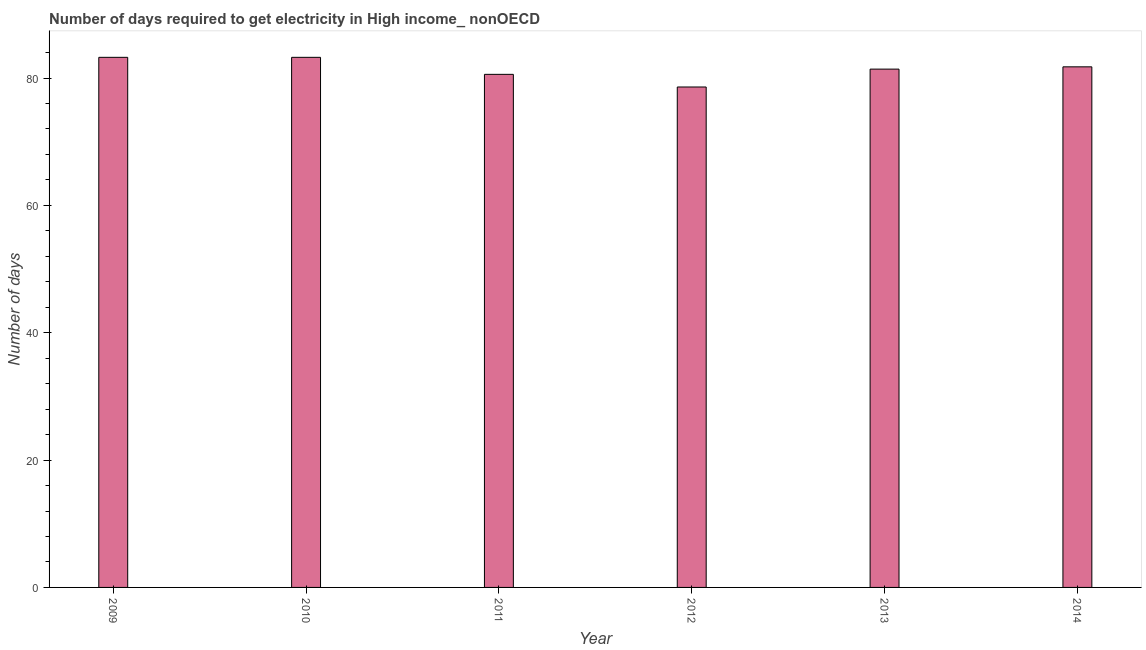Does the graph contain grids?
Give a very brief answer. No. What is the title of the graph?
Provide a short and direct response. Number of days required to get electricity in High income_ nonOECD. What is the label or title of the X-axis?
Offer a very short reply. Year. What is the label or title of the Y-axis?
Offer a terse response. Number of days. What is the time to get electricity in 2011?
Provide a short and direct response. 80.58. Across all years, what is the maximum time to get electricity?
Provide a succinct answer. 83.25. Across all years, what is the minimum time to get electricity?
Make the answer very short. 78.59. In which year was the time to get electricity maximum?
Provide a succinct answer. 2009. What is the sum of the time to get electricity?
Provide a short and direct response. 488.83. What is the difference between the time to get electricity in 2011 and 2013?
Your answer should be very brief. -0.82. What is the average time to get electricity per year?
Make the answer very short. 81.47. What is the median time to get electricity?
Provide a short and direct response. 81.58. In how many years, is the time to get electricity greater than 68 ?
Offer a very short reply. 6. Do a majority of the years between 2009 and 2010 (inclusive) have time to get electricity greater than 16 ?
Your answer should be compact. Yes. Is the difference between the time to get electricity in 2009 and 2014 greater than the difference between any two years?
Keep it short and to the point. No. What is the difference between the highest and the second highest time to get electricity?
Provide a short and direct response. 0. What is the difference between the highest and the lowest time to get electricity?
Your answer should be very brief. 4.66. Are all the bars in the graph horizontal?
Your answer should be compact. No. How many years are there in the graph?
Your answer should be compact. 6. Are the values on the major ticks of Y-axis written in scientific E-notation?
Your answer should be compact. No. What is the Number of days of 2009?
Make the answer very short. 83.25. What is the Number of days in 2010?
Provide a succinct answer. 83.25. What is the Number of days of 2011?
Offer a very short reply. 80.58. What is the Number of days of 2012?
Provide a short and direct response. 78.59. What is the Number of days of 2013?
Keep it short and to the point. 81.4. What is the Number of days in 2014?
Your response must be concise. 81.76. What is the difference between the Number of days in 2009 and 2011?
Provide a short and direct response. 2.67. What is the difference between the Number of days in 2009 and 2012?
Your response must be concise. 4.66. What is the difference between the Number of days in 2009 and 2013?
Keep it short and to the point. 1.85. What is the difference between the Number of days in 2009 and 2014?
Give a very brief answer. 1.49. What is the difference between the Number of days in 2010 and 2011?
Provide a short and direct response. 2.67. What is the difference between the Number of days in 2010 and 2012?
Your answer should be very brief. 4.66. What is the difference between the Number of days in 2010 and 2013?
Your answer should be very brief. 1.85. What is the difference between the Number of days in 2010 and 2014?
Your answer should be very brief. 1.49. What is the difference between the Number of days in 2011 and 2012?
Give a very brief answer. 1.98. What is the difference between the Number of days in 2011 and 2013?
Your answer should be compact. -0.82. What is the difference between the Number of days in 2011 and 2014?
Your answer should be compact. -1.18. What is the difference between the Number of days in 2012 and 2013?
Make the answer very short. -2.81. What is the difference between the Number of days in 2012 and 2014?
Your answer should be very brief. -3.16. What is the difference between the Number of days in 2013 and 2014?
Provide a succinct answer. -0.36. What is the ratio of the Number of days in 2009 to that in 2010?
Provide a short and direct response. 1. What is the ratio of the Number of days in 2009 to that in 2011?
Your answer should be very brief. 1.03. What is the ratio of the Number of days in 2009 to that in 2012?
Your response must be concise. 1.06. What is the ratio of the Number of days in 2009 to that in 2013?
Your answer should be compact. 1.02. What is the ratio of the Number of days in 2009 to that in 2014?
Offer a very short reply. 1.02. What is the ratio of the Number of days in 2010 to that in 2011?
Make the answer very short. 1.03. What is the ratio of the Number of days in 2010 to that in 2012?
Provide a succinct answer. 1.06. What is the ratio of the Number of days in 2011 to that in 2012?
Your answer should be compact. 1.02. What is the ratio of the Number of days in 2011 to that in 2013?
Offer a very short reply. 0.99. What is the ratio of the Number of days in 2011 to that in 2014?
Give a very brief answer. 0.99. 